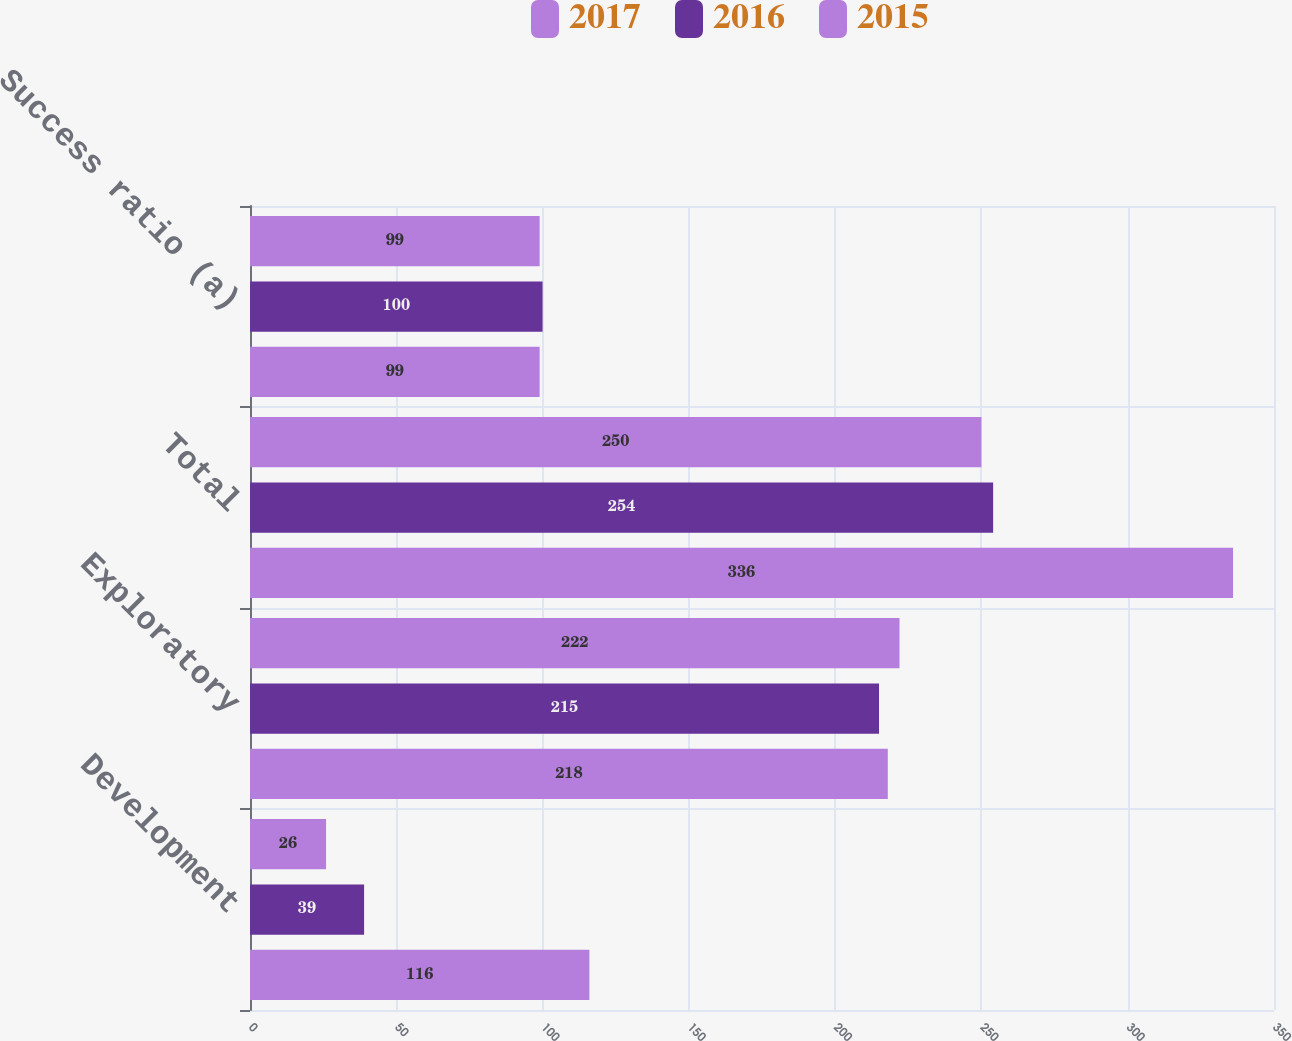<chart> <loc_0><loc_0><loc_500><loc_500><stacked_bar_chart><ecel><fcel>Development<fcel>Exploratory<fcel>Total<fcel>Success ratio (a)<nl><fcel>2017<fcel>26<fcel>222<fcel>250<fcel>99<nl><fcel>2016<fcel>39<fcel>215<fcel>254<fcel>100<nl><fcel>2015<fcel>116<fcel>218<fcel>336<fcel>99<nl></chart> 